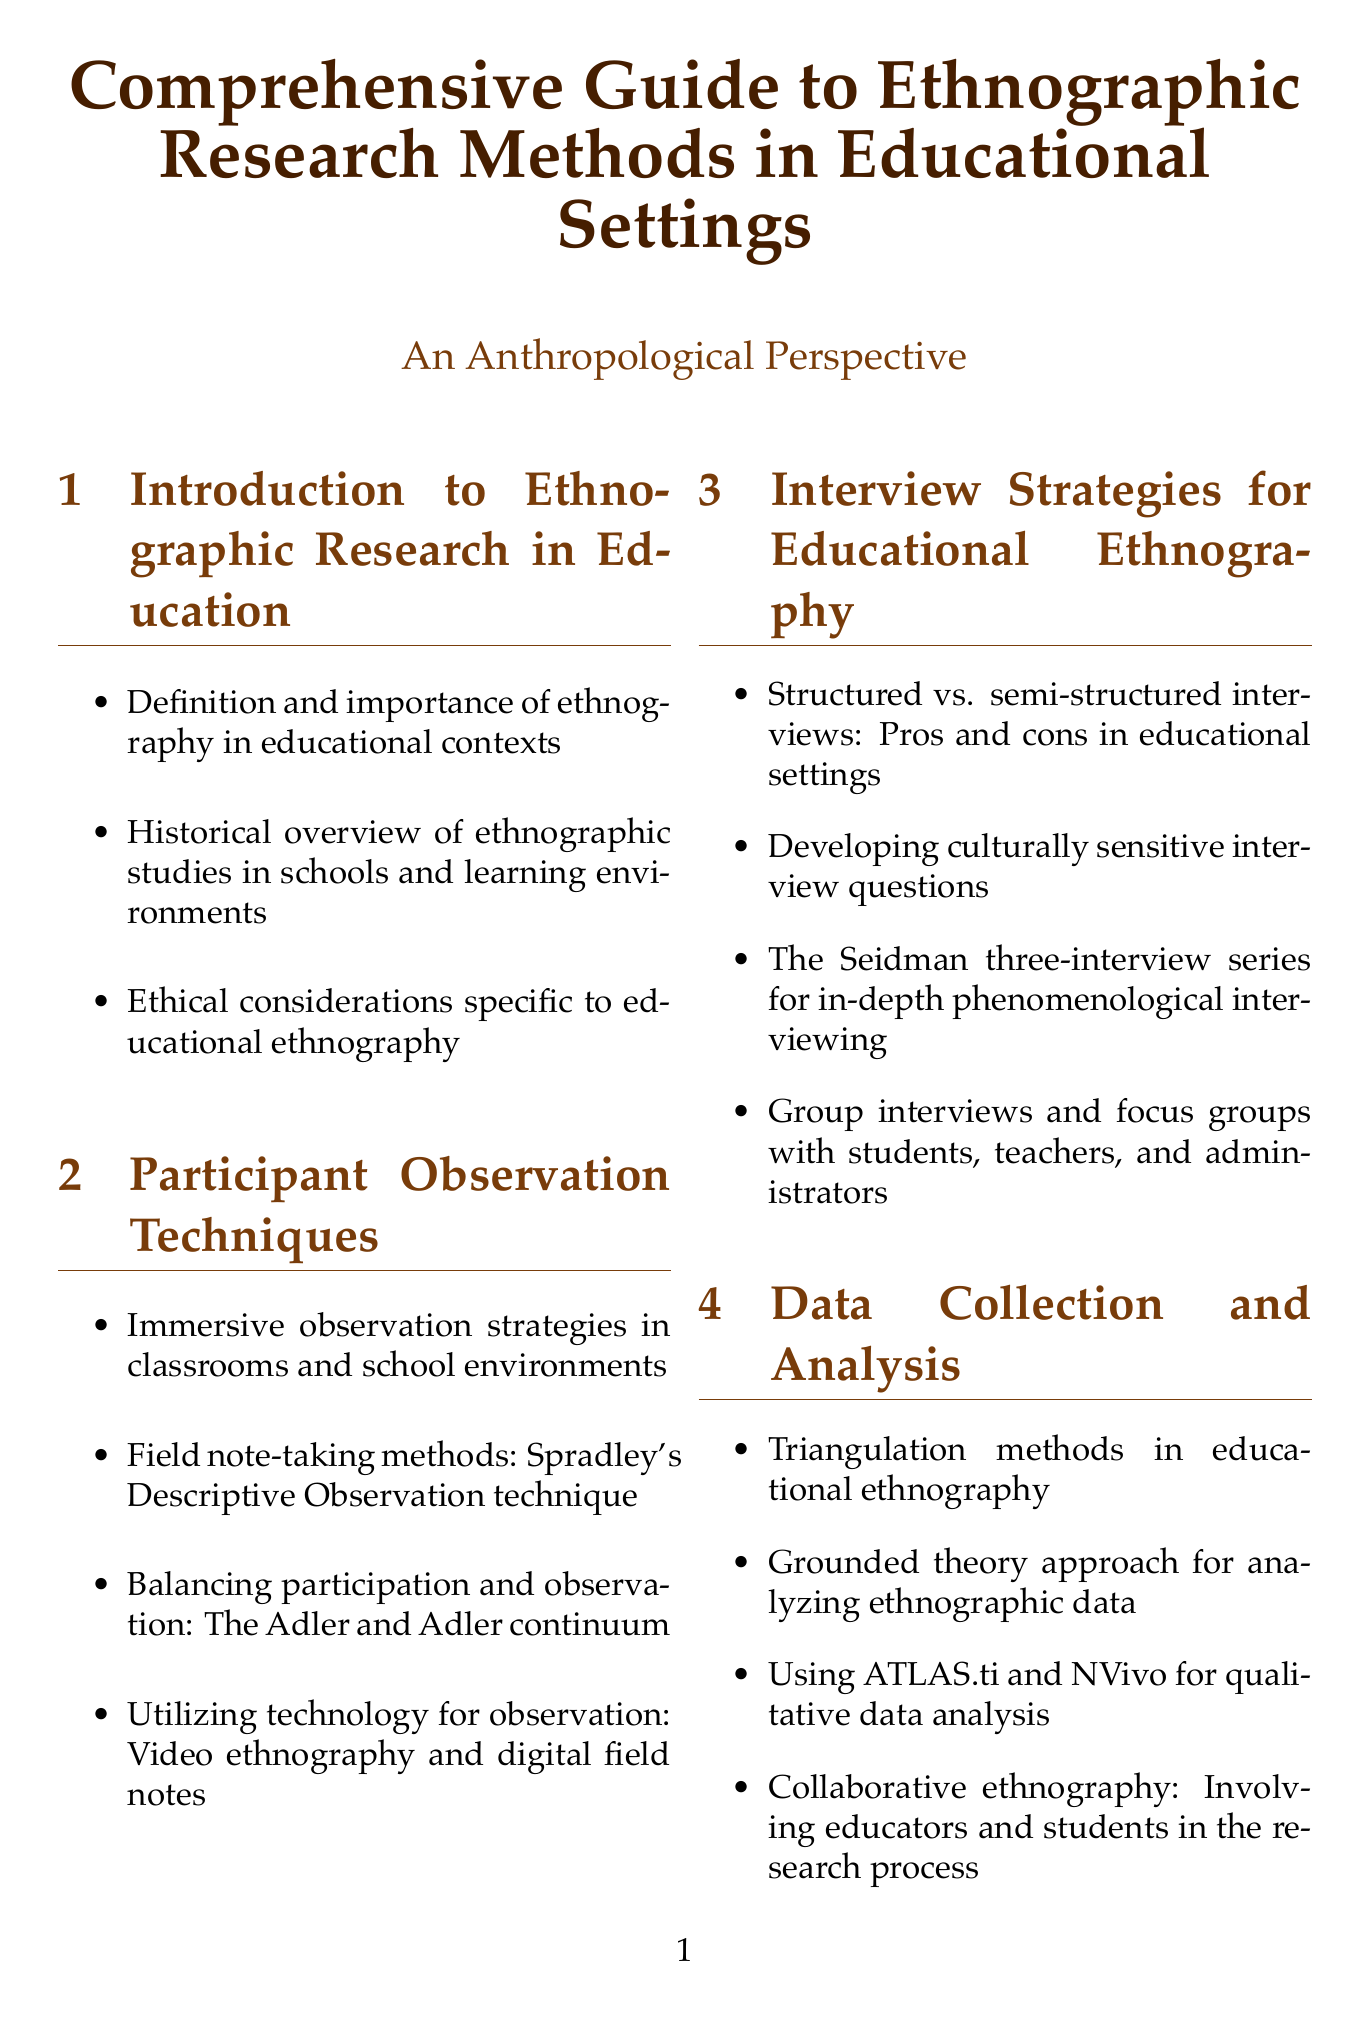What is the title of the document? The title of the document is explicitly stated at the beginning of the document.
Answer: Comprehensive Guide to Ethnographic Research Methods in Educational Settings Who conducted an ethnography titled 'Learning to Labour'? This refers to a specific case study highlighted in the document that focuses on a particular researcher and their work.
Answer: Paul Willis What technique is mentioned for note-taking in participant observation? This information is found in the section discussing participant observation techniques, mentioning a specific method.
Answer: Spradley's Descriptive Observation technique What method is suggested for analyzing qualitative data? The document provides specific software tools used for qualitative data analysis in the data collection and analysis section.
Answer: ATLAS.ti and NVivo What is the focus of Shirley Brice Heath's case study? This refers to the content provided about a case study that examines specific social interactions.
Answer: Language socialization across communities Which section addresses the impact of home culture on academic performance? This section deals explicitly with cultural influences on education.
Answer: Cultural Practices and Educational Outcomes What type of interviews are compared in the document? This question pertains to the part discussing the advantages and disadvantages of two types of interviewing strategies.
Answer: Structured vs. semi-structured What is the name of the organization focused on anthropology and education? This name is listed under professional organizations relevant to the field described in the document.
Answer: Council on Anthropology and Education What qualitative research technique involves reflexivity and positionality? This technique is highlighted in the advanced techniques section of the document.
Answer: Auto-ethnography 